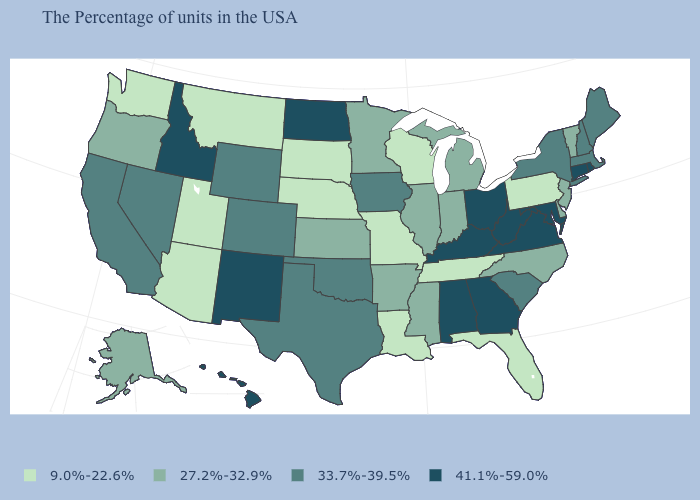What is the value of Montana?
Give a very brief answer. 9.0%-22.6%. Is the legend a continuous bar?
Keep it brief. No. Does Washington have the highest value in the West?
Quick response, please. No. What is the value of Maryland?
Give a very brief answer. 41.1%-59.0%. What is the value of Colorado?
Short answer required. 33.7%-39.5%. What is the value of Pennsylvania?
Give a very brief answer. 9.0%-22.6%. Does New York have a higher value than New Jersey?
Write a very short answer. Yes. What is the highest value in the USA?
Answer briefly. 41.1%-59.0%. Does Kansas have the lowest value in the MidWest?
Be succinct. No. What is the highest value in the South ?
Concise answer only. 41.1%-59.0%. Name the states that have a value in the range 27.2%-32.9%?
Be succinct. Vermont, New Jersey, Delaware, North Carolina, Michigan, Indiana, Illinois, Mississippi, Arkansas, Minnesota, Kansas, Oregon, Alaska. Name the states that have a value in the range 9.0%-22.6%?
Answer briefly. Pennsylvania, Florida, Tennessee, Wisconsin, Louisiana, Missouri, Nebraska, South Dakota, Utah, Montana, Arizona, Washington. Name the states that have a value in the range 41.1%-59.0%?
Give a very brief answer. Rhode Island, Connecticut, Maryland, Virginia, West Virginia, Ohio, Georgia, Kentucky, Alabama, North Dakota, New Mexico, Idaho, Hawaii. What is the lowest value in states that border New York?
Keep it brief. 9.0%-22.6%. Name the states that have a value in the range 33.7%-39.5%?
Answer briefly. Maine, Massachusetts, New Hampshire, New York, South Carolina, Iowa, Oklahoma, Texas, Wyoming, Colorado, Nevada, California. 